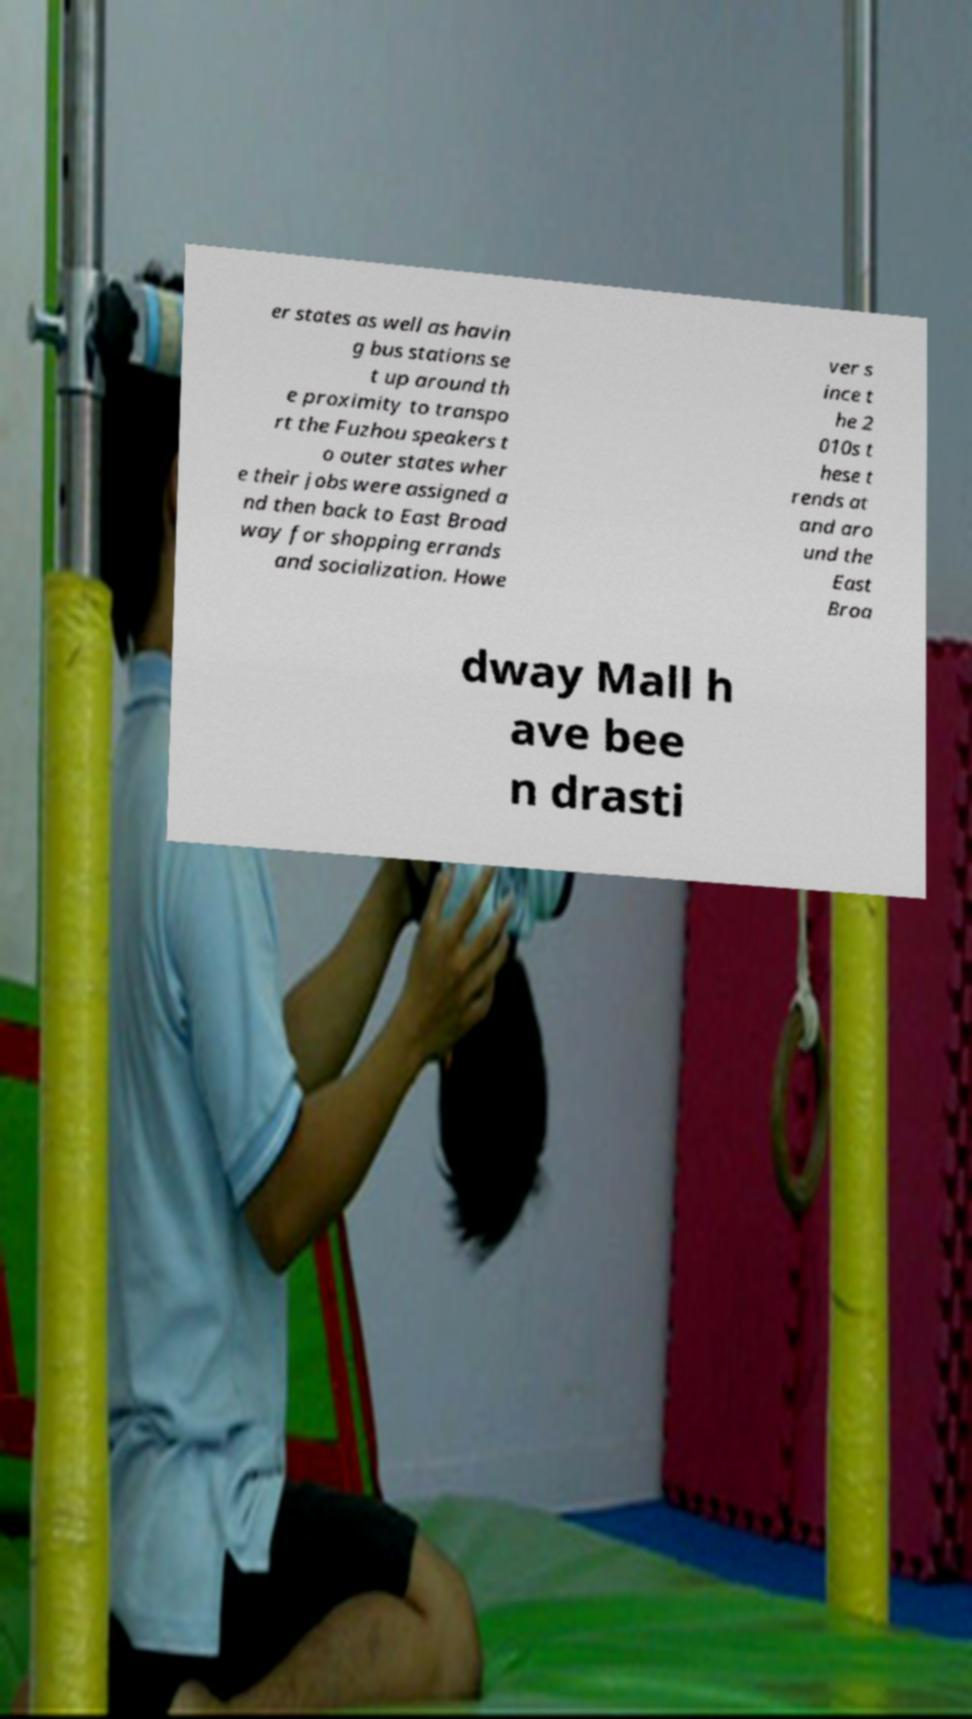I need the written content from this picture converted into text. Can you do that? er states as well as havin g bus stations se t up around th e proximity to transpo rt the Fuzhou speakers t o outer states wher e their jobs were assigned a nd then back to East Broad way for shopping errands and socialization. Howe ver s ince t he 2 010s t hese t rends at and aro und the East Broa dway Mall h ave bee n drasti 